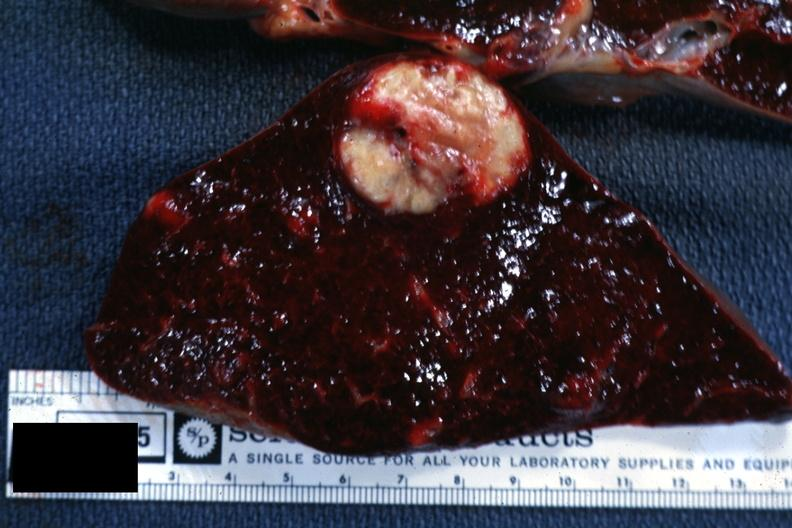s wound present?
Answer the question using a single word or phrase. No 